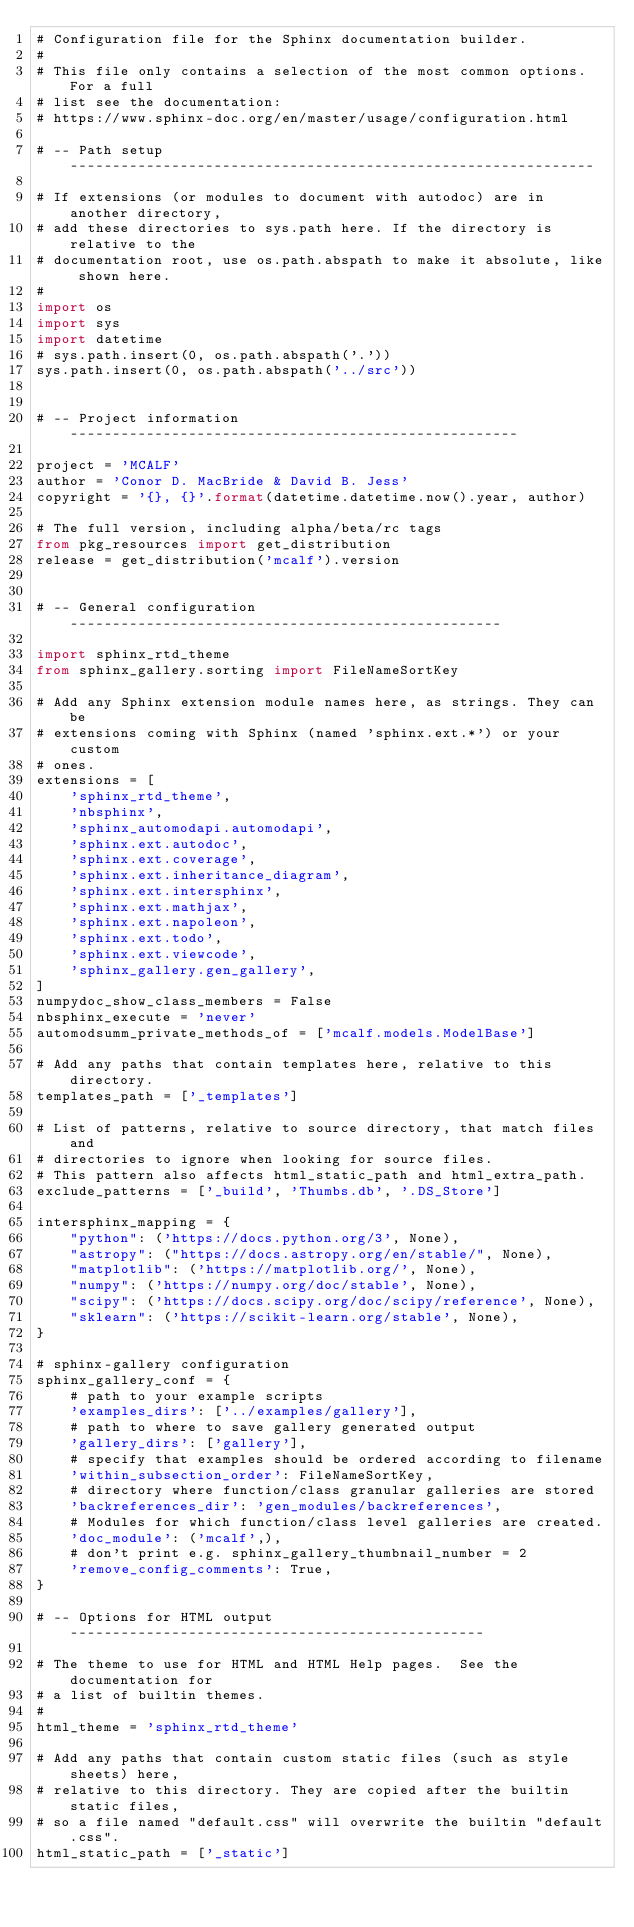Convert code to text. <code><loc_0><loc_0><loc_500><loc_500><_Python_># Configuration file for the Sphinx documentation builder.
#
# This file only contains a selection of the most common options. For a full
# list see the documentation:
# https://www.sphinx-doc.org/en/master/usage/configuration.html

# -- Path setup --------------------------------------------------------------

# If extensions (or modules to document with autodoc) are in another directory,
# add these directories to sys.path here. If the directory is relative to the
# documentation root, use os.path.abspath to make it absolute, like shown here.
#
import os
import sys
import datetime
# sys.path.insert(0, os.path.abspath('.'))
sys.path.insert(0, os.path.abspath('../src'))


# -- Project information -----------------------------------------------------

project = 'MCALF'
author = 'Conor D. MacBride & David B. Jess'
copyright = '{}, {}'.format(datetime.datetime.now().year, author)

# The full version, including alpha/beta/rc tags
from pkg_resources import get_distribution
release = get_distribution('mcalf').version


# -- General configuration ---------------------------------------------------

import sphinx_rtd_theme
from sphinx_gallery.sorting import FileNameSortKey

# Add any Sphinx extension module names here, as strings. They can be
# extensions coming with Sphinx (named 'sphinx.ext.*') or your custom
# ones.
extensions = [
    'sphinx_rtd_theme',
    'nbsphinx',
    'sphinx_automodapi.automodapi',
    'sphinx.ext.autodoc',
    'sphinx.ext.coverage',
    'sphinx.ext.inheritance_diagram',
    'sphinx.ext.intersphinx',
    'sphinx.ext.mathjax',
    'sphinx.ext.napoleon',
    'sphinx.ext.todo',
    'sphinx.ext.viewcode',
    'sphinx_gallery.gen_gallery',
]
numpydoc_show_class_members = False
nbsphinx_execute = 'never'
automodsumm_private_methods_of = ['mcalf.models.ModelBase']

# Add any paths that contain templates here, relative to this directory.
templates_path = ['_templates']

# List of patterns, relative to source directory, that match files and
# directories to ignore when looking for source files.
# This pattern also affects html_static_path and html_extra_path.
exclude_patterns = ['_build', 'Thumbs.db', '.DS_Store']

intersphinx_mapping = {
    "python": ('https://docs.python.org/3', None),
    "astropy": ("https://docs.astropy.org/en/stable/", None),
    "matplotlib": ('https://matplotlib.org/', None),
    "numpy": ('https://numpy.org/doc/stable', None),
    "scipy": ('https://docs.scipy.org/doc/scipy/reference', None),
    "sklearn": ('https://scikit-learn.org/stable', None),
}

# sphinx-gallery configuration
sphinx_gallery_conf = {
    # path to your example scripts
    'examples_dirs': ['../examples/gallery'],
    # path to where to save gallery generated output
    'gallery_dirs': ['gallery'],
    # specify that examples should be ordered according to filename
    'within_subsection_order': FileNameSortKey,
    # directory where function/class granular galleries are stored
    'backreferences_dir': 'gen_modules/backreferences',
    # Modules for which function/class level galleries are created.
    'doc_module': ('mcalf',),
    # don't print e.g. sphinx_gallery_thumbnail_number = 2
    'remove_config_comments': True,
}

# -- Options for HTML output -------------------------------------------------

# The theme to use for HTML and HTML Help pages.  See the documentation for
# a list of builtin themes.
#
html_theme = 'sphinx_rtd_theme'

# Add any paths that contain custom static files (such as style sheets) here,
# relative to this directory. They are copied after the builtin static files,
# so a file named "default.css" will overwrite the builtin "default.css".
html_static_path = ['_static']
</code> 